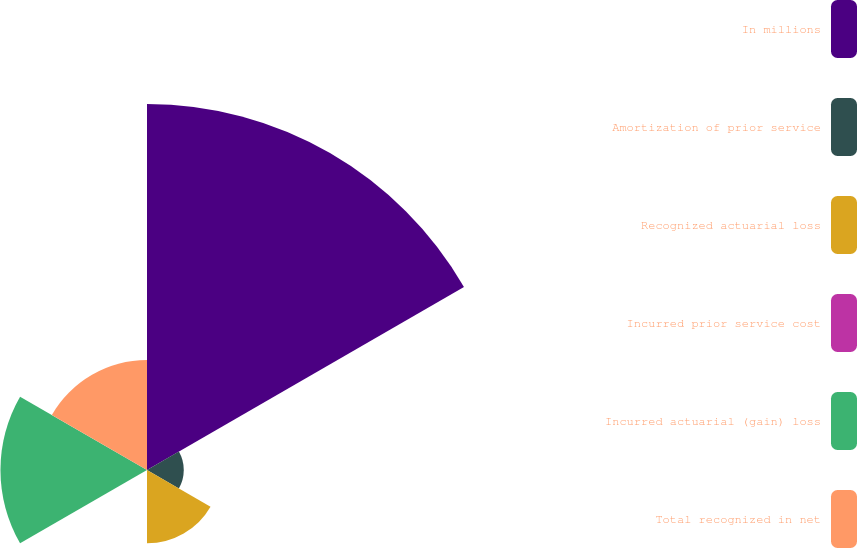Convert chart to OTSL. <chart><loc_0><loc_0><loc_500><loc_500><pie_chart><fcel>In millions<fcel>Amortization of prior service<fcel>Recognized actuarial loss<fcel>Incurred prior service cost<fcel>Incurred actuarial (gain) loss<fcel>Total recognized in net<nl><fcel>49.95%<fcel>5.02%<fcel>10.01%<fcel>0.02%<fcel>20.0%<fcel>15.0%<nl></chart> 